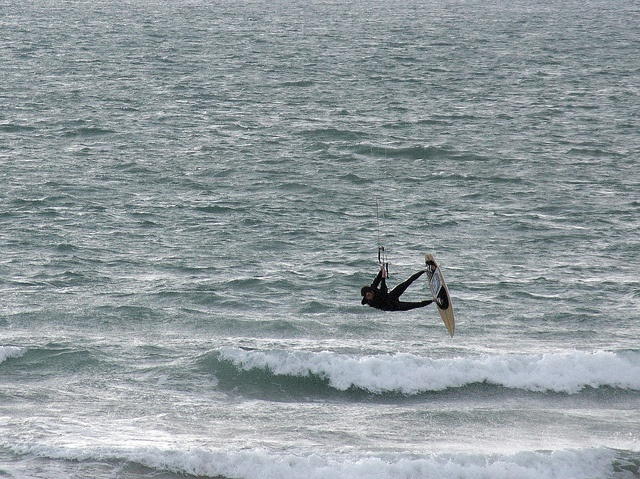Describe the objects in this image and their specific colors. I can see people in gray, black, and darkgray tones and surfboard in gray, darkgray, and black tones in this image. 